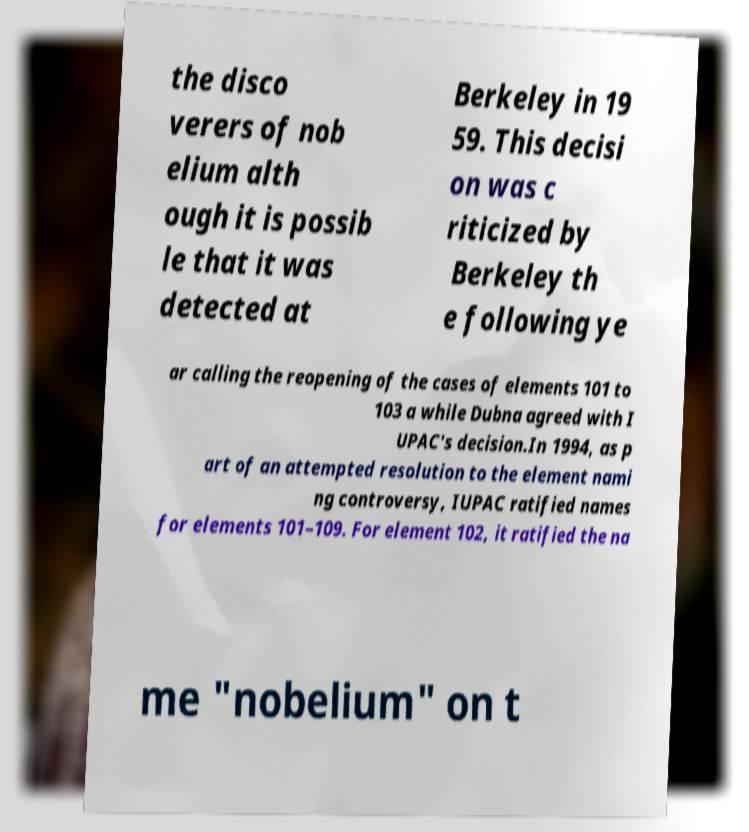Please identify and transcribe the text found in this image. the disco verers of nob elium alth ough it is possib le that it was detected at Berkeley in 19 59. This decisi on was c riticized by Berkeley th e following ye ar calling the reopening of the cases of elements 101 to 103 a while Dubna agreed with I UPAC's decision.In 1994, as p art of an attempted resolution to the element nami ng controversy, IUPAC ratified names for elements 101–109. For element 102, it ratified the na me "nobelium" on t 